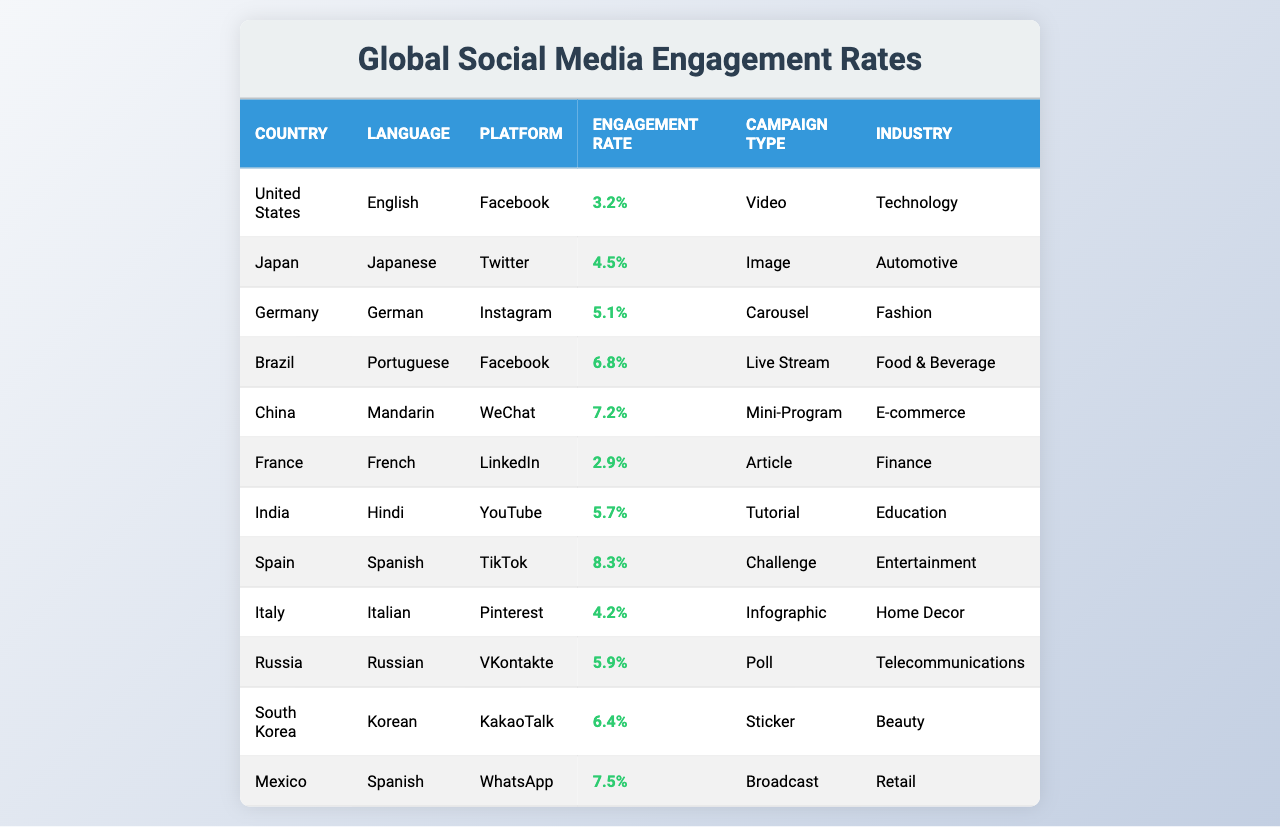What is the highest engagement rate among the campaigns? By reviewing the engagement rates listed in the table, we find Brazil at 6.8%, China at 7.2%, Spain at 8.3%, and Mexico at 7.5%. The highest value is 8.3% for Spain.
Answer: 8.3% In which country is the lowest engagement rate recorded? Looking through the engagement rates, the lowest is 2.9%, which is associated with France.
Answer: France What total engagement rate do the campaigns from Spanish-speaking countries have? We find two Spanish-speaking countries: Spain with 8.3% and Mexico with 7.5%. Adding these gives us a total engagement rate of 8.3 + 7.5 = 15.8%.
Answer: 15.8% Is the engagement rate for campaigns in the automotive industry higher than that in the technology industry? The engagement rates for the automotive (Japan, 4.5%) and technology (United States, 3.2%) industries are compared. 4.5% > 3.2%, so yes.
Answer: Yes What is the average engagement rate for campaigns in European countries? The relevant countries are Germany (5.1%), France (2.9%), Italy (4.2%), and Spain (8.3%). Summing these gives 5.1 + 2.9 + 4.2 + 8.3 = 20.5, and dividing by 4 (number of countries) gives an average of 20.5/4 = 5.125%.
Answer: 5.125% Which platform has the highest engagement rate for its campaign? The rates are as follows: Facebook (6.8%), Twitter (4.5%), Instagram (5.1%), WeChat (7.2%), LinkedIn (2.9%), YouTube (5.7%), TikTok (8.3%), Pinterest (4.2%), VKontakte (5.9%), and KakaoTalk (6.4%). The highest is 8.3% for TikTok.
Answer: TikTok Which industry has the greatest variety of campaign types represented in the table? By examining the industries, we see Technology, Automotive, Fashion, Food & Beverage, E-commerce, Finance, Education, Entertainment, Home Decor, Telecommunications, and Beauty each have differing campaign types. Counting unique industries yields 11 distinct types, indicating no overlap of campaign types within a single industry.
Answer: 11 Is the engagement rate of a beauty campaign in South Korea higher or lower than the average engagement rate across all countries listed? First, find the average engagement rate: (3.2 + 4.5 + 5.1 + 6.8 + 7.2 + 2.9 + 5.7 + 8.3 + 4.2 + 5.9 + 6.4 + 7.5) / 12 = 5.4. The rate for South Korea (Korean, 6.4%) is higher than the average of 5.4%.
Answer: Higher 